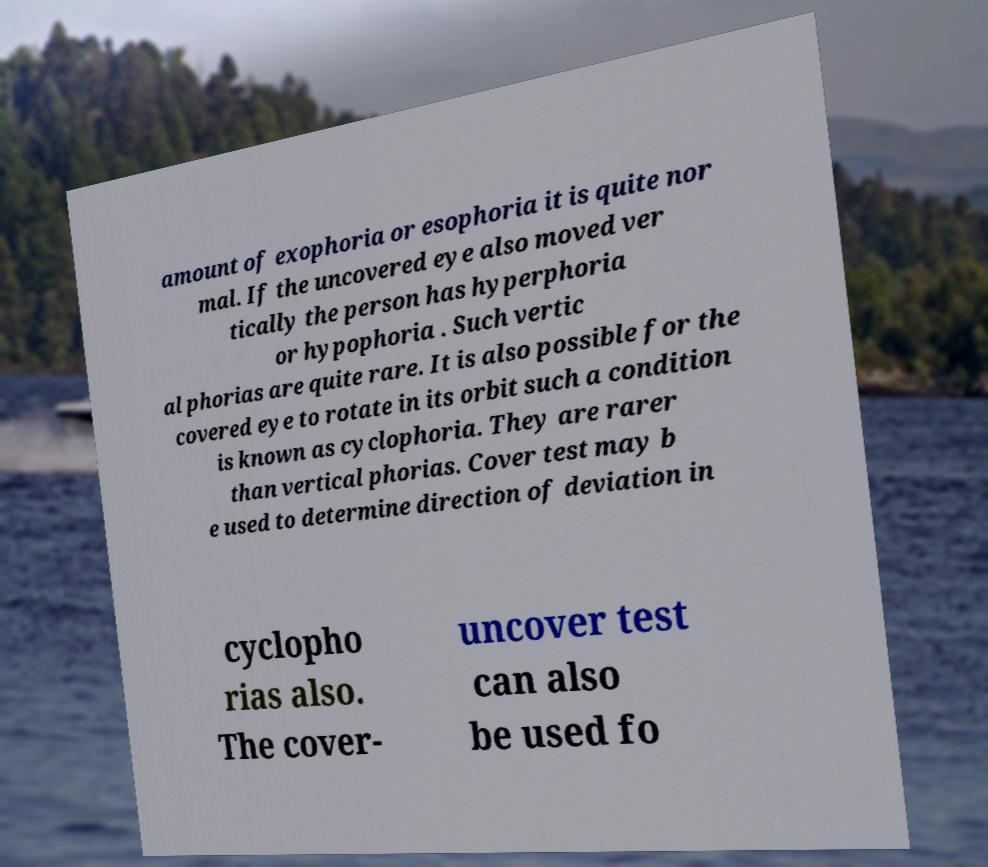Could you extract and type out the text from this image? amount of exophoria or esophoria it is quite nor mal. If the uncovered eye also moved ver tically the person has hyperphoria or hypophoria . Such vertic al phorias are quite rare. It is also possible for the covered eye to rotate in its orbit such a condition is known as cyclophoria. They are rarer than vertical phorias. Cover test may b e used to determine direction of deviation in cyclopho rias also. The cover- uncover test can also be used fo 